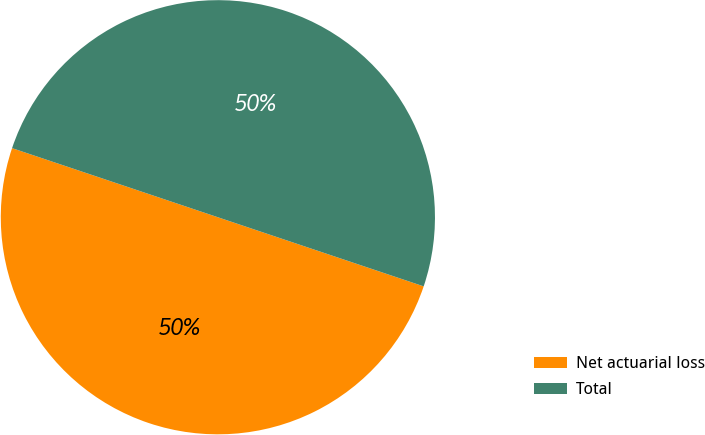Convert chart. <chart><loc_0><loc_0><loc_500><loc_500><pie_chart><fcel>Net actuarial loss<fcel>Total<nl><fcel>50.0%<fcel>50.0%<nl></chart> 